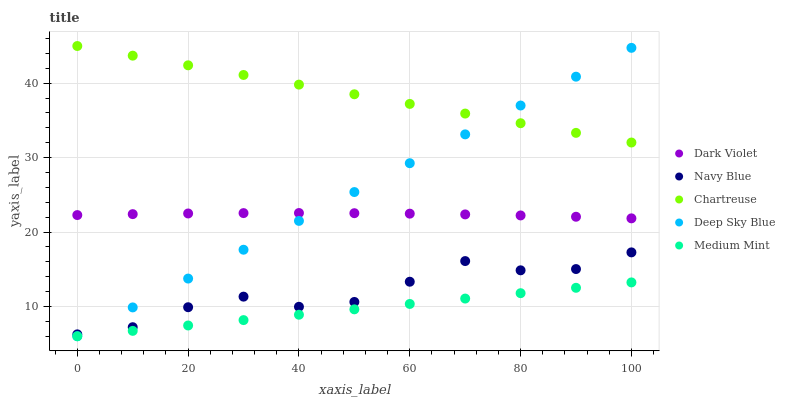Does Medium Mint have the minimum area under the curve?
Answer yes or no. Yes. Does Chartreuse have the maximum area under the curve?
Answer yes or no. Yes. Does Navy Blue have the minimum area under the curve?
Answer yes or no. No. Does Navy Blue have the maximum area under the curve?
Answer yes or no. No. Is Medium Mint the smoothest?
Answer yes or no. Yes. Is Navy Blue the roughest?
Answer yes or no. Yes. Is Chartreuse the smoothest?
Answer yes or no. No. Is Chartreuse the roughest?
Answer yes or no. No. Does Medium Mint have the lowest value?
Answer yes or no. Yes. Does Navy Blue have the lowest value?
Answer yes or no. No. Does Chartreuse have the highest value?
Answer yes or no. Yes. Does Navy Blue have the highest value?
Answer yes or no. No. Is Medium Mint less than Navy Blue?
Answer yes or no. Yes. Is Chartreuse greater than Dark Violet?
Answer yes or no. Yes. Does Medium Mint intersect Deep Sky Blue?
Answer yes or no. Yes. Is Medium Mint less than Deep Sky Blue?
Answer yes or no. No. Is Medium Mint greater than Deep Sky Blue?
Answer yes or no. No. Does Medium Mint intersect Navy Blue?
Answer yes or no. No. 